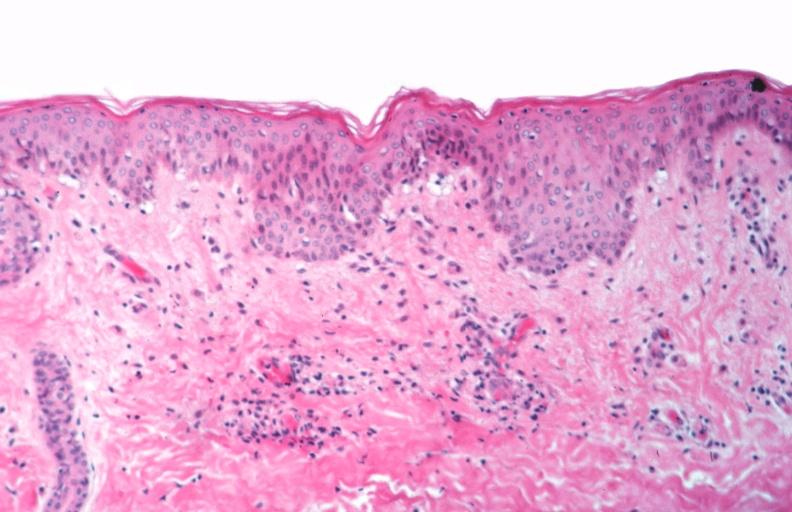what is rocky mountain spotted?
Answer the question using a single word or phrase. Fever 